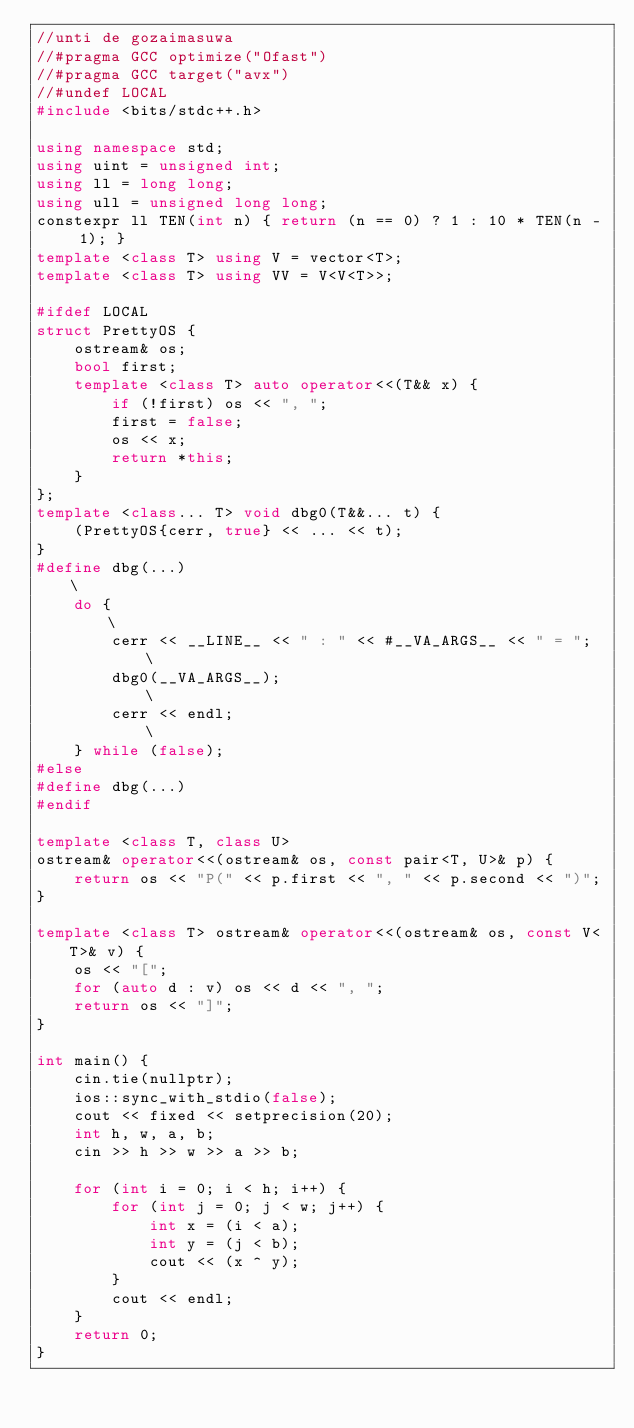Convert code to text. <code><loc_0><loc_0><loc_500><loc_500><_C++_>//unti de gozaimasuwa
//#pragma GCC optimize("Ofast")
//#pragma GCC target("avx")
//#undef LOCAL
#include <bits/stdc++.h>

using namespace std;
using uint = unsigned int;
using ll = long long;
using ull = unsigned long long;
constexpr ll TEN(int n) { return (n == 0) ? 1 : 10 * TEN(n - 1); }
template <class T> using V = vector<T>;
template <class T> using VV = V<V<T>>;

#ifdef LOCAL
struct PrettyOS {
    ostream& os;
    bool first;
    template <class T> auto operator<<(T&& x) {
        if (!first) os << ", ";
        first = false;
        os << x;
        return *this;
    }
};
template <class... T> void dbg0(T&&... t) {
    (PrettyOS{cerr, true} << ... << t);
}
#define dbg(...)                                            \
    do {                                                    \
        cerr << __LINE__ << " : " << #__VA_ARGS__ << " = "; \
        dbg0(__VA_ARGS__);                                  \
        cerr << endl;                                       \
    } while (false);
#else
#define dbg(...)
#endif

template <class T, class U>
ostream& operator<<(ostream& os, const pair<T, U>& p) {
    return os << "P(" << p.first << ", " << p.second << ")";
}

template <class T> ostream& operator<<(ostream& os, const V<T>& v) {
    os << "[";
    for (auto d : v) os << d << ", ";
    return os << "]";
}

int main() {
    cin.tie(nullptr);
    ios::sync_with_stdio(false);
    cout << fixed << setprecision(20);
    int h, w, a, b;
    cin >> h >> w >> a >> b;
    
    for (int i = 0; i < h; i++) {
        for (int j = 0; j < w; j++) {
            int x = (i < a);
            int y = (j < b);
            cout << (x ^ y);
        }
        cout << endl;
    }
    return 0;
}
</code> 